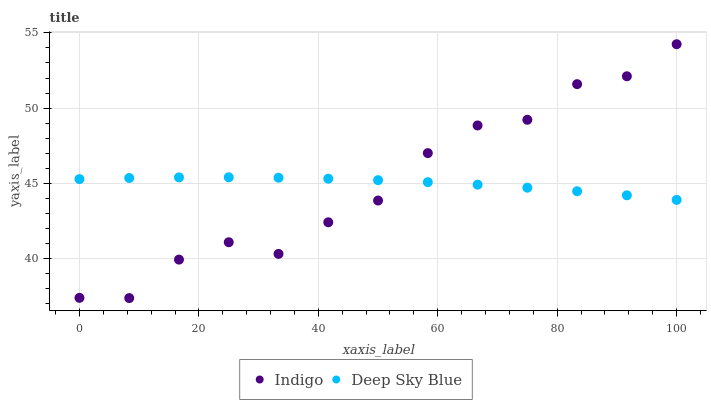Does Indigo have the minimum area under the curve?
Answer yes or no. Yes. Does Deep Sky Blue have the maximum area under the curve?
Answer yes or no. Yes. Does Deep Sky Blue have the minimum area under the curve?
Answer yes or no. No. Is Deep Sky Blue the smoothest?
Answer yes or no. Yes. Is Indigo the roughest?
Answer yes or no. Yes. Is Deep Sky Blue the roughest?
Answer yes or no. No. Does Indigo have the lowest value?
Answer yes or no. Yes. Does Deep Sky Blue have the lowest value?
Answer yes or no. No. Does Indigo have the highest value?
Answer yes or no. Yes. Does Deep Sky Blue have the highest value?
Answer yes or no. No. Does Indigo intersect Deep Sky Blue?
Answer yes or no. Yes. Is Indigo less than Deep Sky Blue?
Answer yes or no. No. Is Indigo greater than Deep Sky Blue?
Answer yes or no. No. 